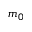Convert formula to latex. <formula><loc_0><loc_0><loc_500><loc_500>m _ { 0 }</formula> 